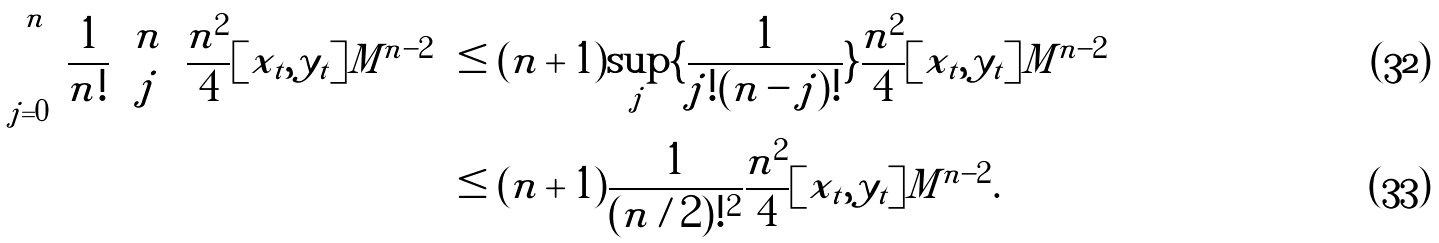Convert formula to latex. <formula><loc_0><loc_0><loc_500><loc_500>\sum _ { j = 0 } ^ { n } \frac { 1 } { n ! } { n \choose j } \frac { n ^ { 2 } } { 4 } \| [ x _ { t } , y _ { t } ] \| M ^ { n - 2 } & \leq ( n + 1 ) \sup _ { j } \{ \frac { 1 } { j ! ( n - j ) ! } \} \frac { n ^ { 2 } } { 4 } \| [ x _ { t } , y _ { t } ] \| M ^ { n - 2 } \\ & \leq ( n + 1 ) \frac { 1 } { ( n / 2 ) ! ^ { 2 } } \frac { n ^ { 2 } } { 4 } \| [ x _ { t } , y _ { t } ] \| M ^ { n - 2 } .</formula> 